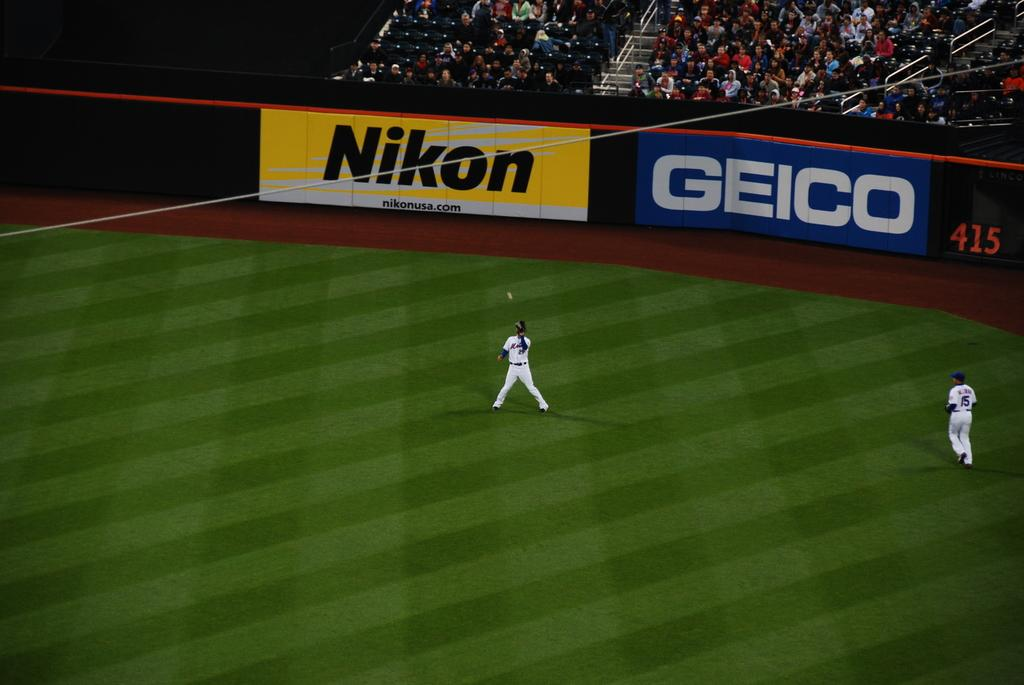<image>
Share a concise interpretation of the image provided. A Geico ad can be seen on a baseball field. 